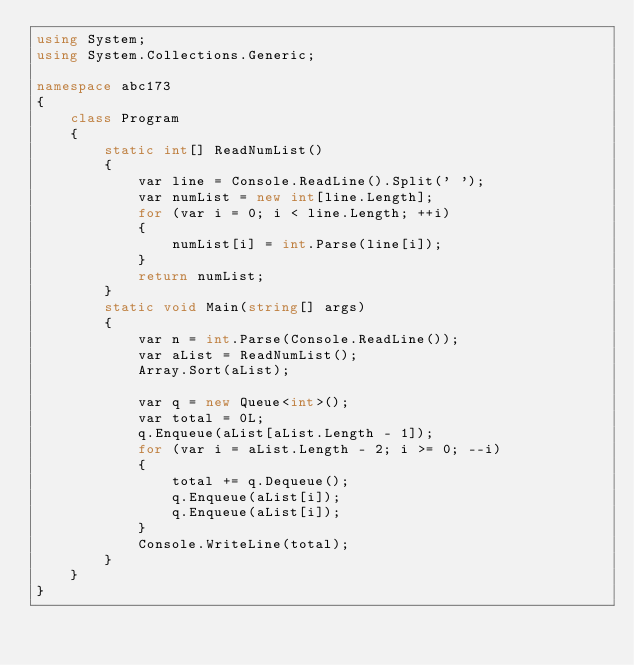<code> <loc_0><loc_0><loc_500><loc_500><_C#_>using System;
using System.Collections.Generic;

namespace abc173
{
    class Program
    {
        static int[] ReadNumList()
        {
            var line = Console.ReadLine().Split(' ');
            var numList = new int[line.Length];
            for (var i = 0; i < line.Length; ++i)
            {
                numList[i] = int.Parse(line[i]);
            }
            return numList;
        }
        static void Main(string[] args)
        {
            var n = int.Parse(Console.ReadLine());
            var aList = ReadNumList();
            Array.Sort(aList);

            var q = new Queue<int>();
            var total = 0L;
            q.Enqueue(aList[aList.Length - 1]);
            for (var i = aList.Length - 2; i >= 0; --i)
            {
                total += q.Dequeue();
                q.Enqueue(aList[i]);
                q.Enqueue(aList[i]);
            }
            Console.WriteLine(total);
        }
    }
}
</code> 